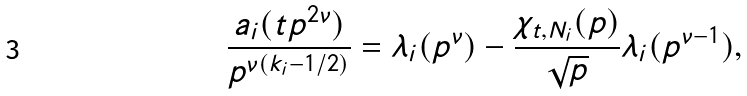<formula> <loc_0><loc_0><loc_500><loc_500>\frac { a _ { i } ( t p ^ { 2 \nu } ) } { p ^ { \nu ( k _ { i } - 1 / 2 ) } } = \lambda _ { i } ( p ^ { \nu } ) - \frac { \chi _ { t , N _ { i } } ( p ) } { \sqrt { p } } \lambda _ { i } ( p ^ { \nu - 1 } ) ,</formula> 